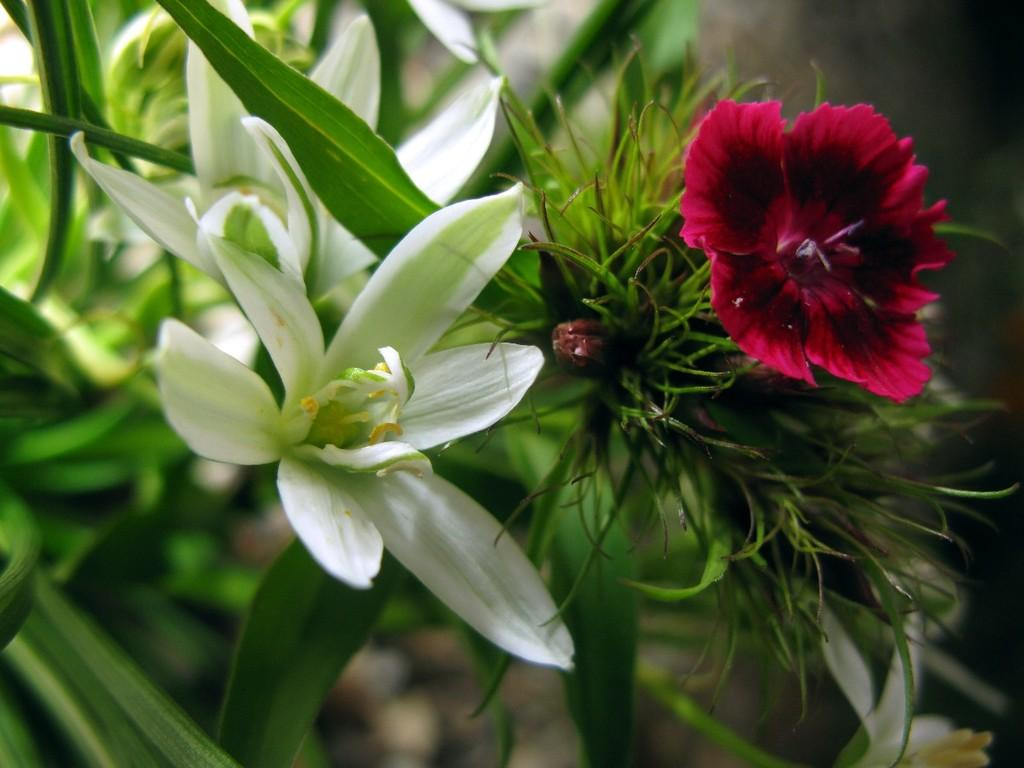What type of living organisms can be seen in the image? The image contains plants and flowers. What colors are the flowers in the image? The flowers in the image are in white and pink color. What type of bike can be seen in the image? There is no bike present in the image. How does the toothbrush help the flowers in the image? There is no toothbrush present in the image, and therefore it cannot help the flowers. 